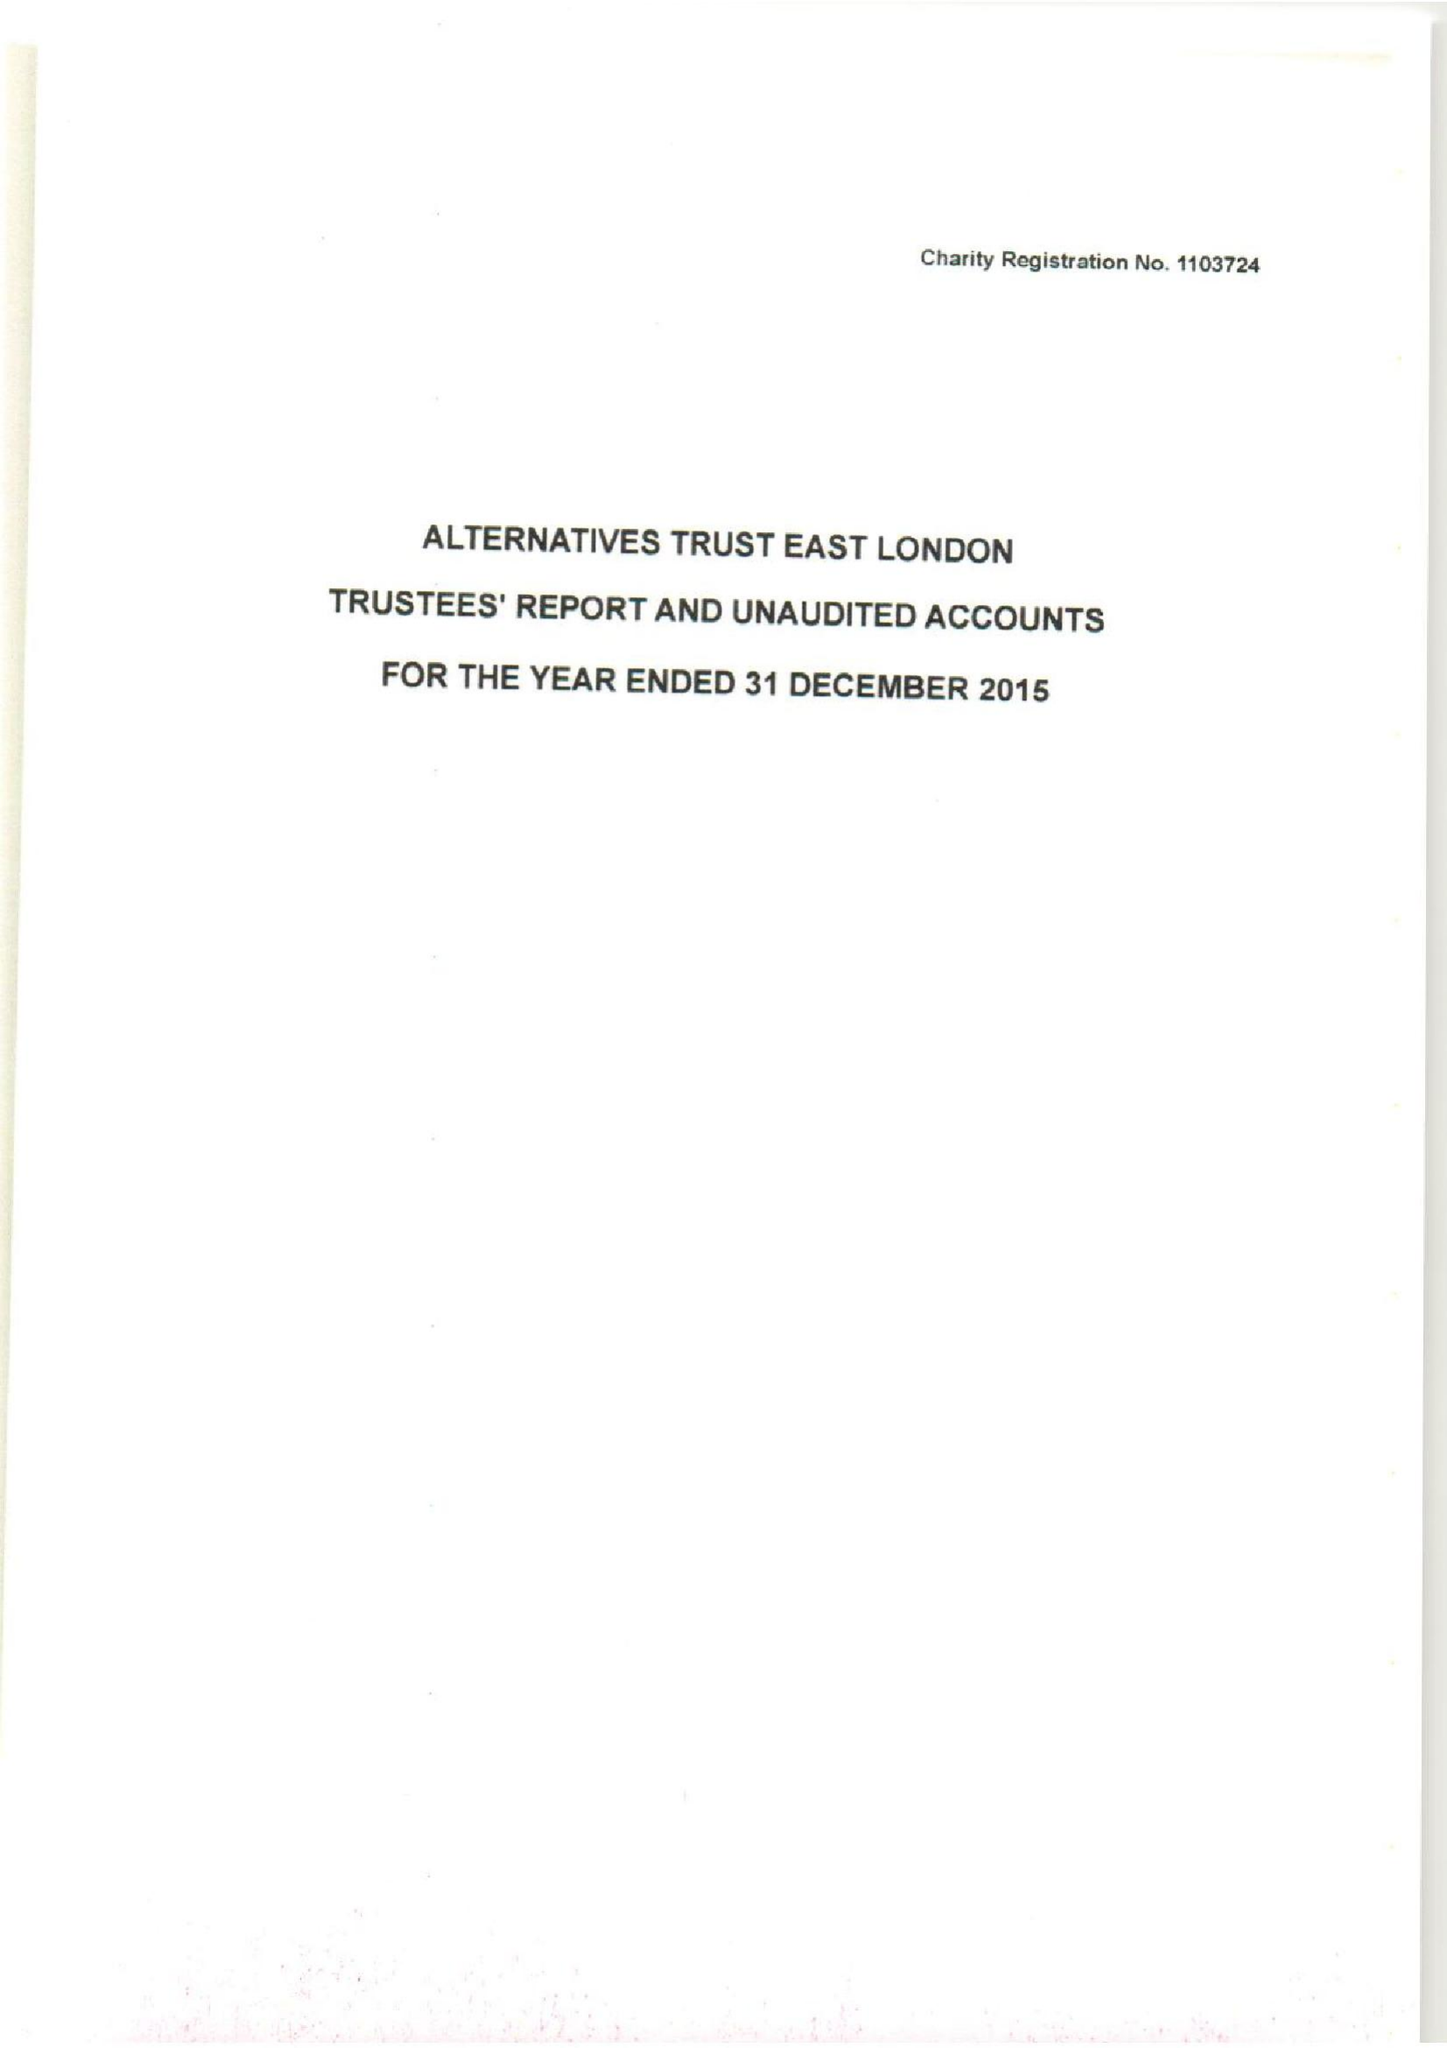What is the value for the address__post_town?
Answer the question using a single word or phrase. LONDON 